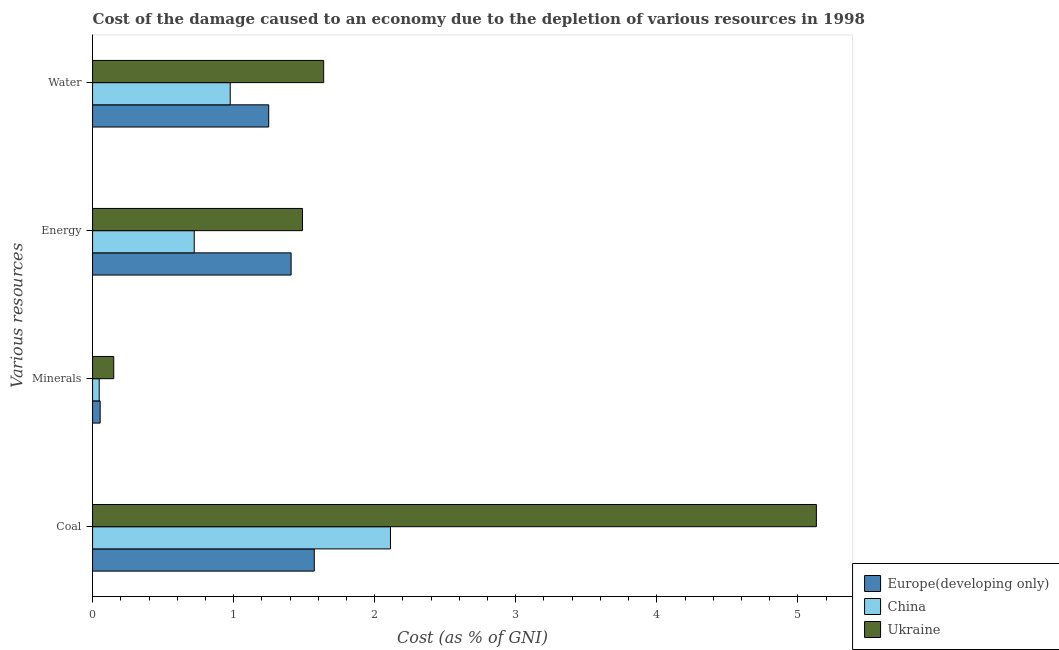How many different coloured bars are there?
Your answer should be compact. 3. How many groups of bars are there?
Your response must be concise. 4. Are the number of bars per tick equal to the number of legend labels?
Provide a short and direct response. Yes. Are the number of bars on each tick of the Y-axis equal?
Provide a short and direct response. Yes. What is the label of the 4th group of bars from the top?
Give a very brief answer. Coal. What is the cost of damage due to depletion of minerals in Ukraine?
Keep it short and to the point. 0.15. Across all countries, what is the maximum cost of damage due to depletion of water?
Provide a succinct answer. 1.64. Across all countries, what is the minimum cost of damage due to depletion of energy?
Keep it short and to the point. 0.72. In which country was the cost of damage due to depletion of energy maximum?
Give a very brief answer. Ukraine. What is the total cost of damage due to depletion of energy in the graph?
Keep it short and to the point. 3.62. What is the difference between the cost of damage due to depletion of energy in Ukraine and that in China?
Ensure brevity in your answer.  0.77. What is the difference between the cost of damage due to depletion of minerals in China and the cost of damage due to depletion of energy in Europe(developing only)?
Provide a succinct answer. -1.36. What is the average cost of damage due to depletion of water per country?
Provide a succinct answer. 1.29. What is the difference between the cost of damage due to depletion of energy and cost of damage due to depletion of coal in Ukraine?
Your answer should be compact. -3.64. What is the ratio of the cost of damage due to depletion of energy in Ukraine to that in China?
Offer a very short reply. 2.06. What is the difference between the highest and the second highest cost of damage due to depletion of energy?
Your response must be concise. 0.08. What is the difference between the highest and the lowest cost of damage due to depletion of coal?
Your response must be concise. 3.56. Is the sum of the cost of damage due to depletion of coal in Europe(developing only) and China greater than the maximum cost of damage due to depletion of energy across all countries?
Make the answer very short. Yes. What does the 1st bar from the top in Energy represents?
Make the answer very short. Ukraine. What does the 2nd bar from the bottom in Energy represents?
Offer a terse response. China. Are all the bars in the graph horizontal?
Offer a very short reply. Yes. How many countries are there in the graph?
Ensure brevity in your answer.  3. Does the graph contain any zero values?
Your answer should be compact. No. Does the graph contain grids?
Keep it short and to the point. No. How many legend labels are there?
Ensure brevity in your answer.  3. What is the title of the graph?
Your response must be concise. Cost of the damage caused to an economy due to the depletion of various resources in 1998 . Does "Turkey" appear as one of the legend labels in the graph?
Offer a very short reply. No. What is the label or title of the X-axis?
Give a very brief answer. Cost (as % of GNI). What is the label or title of the Y-axis?
Your response must be concise. Various resources. What is the Cost (as % of GNI) of Europe(developing only) in Coal?
Your answer should be compact. 1.57. What is the Cost (as % of GNI) of China in Coal?
Your answer should be compact. 2.11. What is the Cost (as % of GNI) in Ukraine in Coal?
Make the answer very short. 5.13. What is the Cost (as % of GNI) of Europe(developing only) in Minerals?
Your answer should be compact. 0.05. What is the Cost (as % of GNI) of China in Minerals?
Your response must be concise. 0.05. What is the Cost (as % of GNI) of Ukraine in Minerals?
Provide a short and direct response. 0.15. What is the Cost (as % of GNI) of Europe(developing only) in Energy?
Ensure brevity in your answer.  1.41. What is the Cost (as % of GNI) in China in Energy?
Provide a short and direct response. 0.72. What is the Cost (as % of GNI) in Ukraine in Energy?
Keep it short and to the point. 1.49. What is the Cost (as % of GNI) in Europe(developing only) in Water?
Your answer should be compact. 1.25. What is the Cost (as % of GNI) in China in Water?
Ensure brevity in your answer.  0.98. What is the Cost (as % of GNI) in Ukraine in Water?
Offer a terse response. 1.64. Across all Various resources, what is the maximum Cost (as % of GNI) of Europe(developing only)?
Make the answer very short. 1.57. Across all Various resources, what is the maximum Cost (as % of GNI) of China?
Your response must be concise. 2.11. Across all Various resources, what is the maximum Cost (as % of GNI) in Ukraine?
Offer a terse response. 5.13. Across all Various resources, what is the minimum Cost (as % of GNI) of Europe(developing only)?
Your answer should be compact. 0.05. Across all Various resources, what is the minimum Cost (as % of GNI) of China?
Your answer should be very brief. 0.05. Across all Various resources, what is the minimum Cost (as % of GNI) in Ukraine?
Your answer should be compact. 0.15. What is the total Cost (as % of GNI) in Europe(developing only) in the graph?
Your answer should be compact. 4.28. What is the total Cost (as % of GNI) in China in the graph?
Give a very brief answer. 3.86. What is the total Cost (as % of GNI) in Ukraine in the graph?
Offer a very short reply. 8.41. What is the difference between the Cost (as % of GNI) in Europe(developing only) in Coal and that in Minerals?
Make the answer very short. 1.52. What is the difference between the Cost (as % of GNI) in China in Coal and that in Minerals?
Your response must be concise. 2.06. What is the difference between the Cost (as % of GNI) of Ukraine in Coal and that in Minerals?
Make the answer very short. 4.98. What is the difference between the Cost (as % of GNI) of Europe(developing only) in Coal and that in Energy?
Make the answer very short. 0.16. What is the difference between the Cost (as % of GNI) in China in Coal and that in Energy?
Provide a short and direct response. 1.39. What is the difference between the Cost (as % of GNI) in Ukraine in Coal and that in Energy?
Offer a terse response. 3.64. What is the difference between the Cost (as % of GNI) in Europe(developing only) in Coal and that in Water?
Provide a succinct answer. 0.32. What is the difference between the Cost (as % of GNI) in China in Coal and that in Water?
Ensure brevity in your answer.  1.14. What is the difference between the Cost (as % of GNI) of Ukraine in Coal and that in Water?
Your answer should be compact. 3.49. What is the difference between the Cost (as % of GNI) of Europe(developing only) in Minerals and that in Energy?
Keep it short and to the point. -1.35. What is the difference between the Cost (as % of GNI) in China in Minerals and that in Energy?
Make the answer very short. -0.67. What is the difference between the Cost (as % of GNI) in Ukraine in Minerals and that in Energy?
Provide a succinct answer. -1.34. What is the difference between the Cost (as % of GNI) in Europe(developing only) in Minerals and that in Water?
Your answer should be very brief. -1.19. What is the difference between the Cost (as % of GNI) in China in Minerals and that in Water?
Offer a very short reply. -0.93. What is the difference between the Cost (as % of GNI) in Ukraine in Minerals and that in Water?
Ensure brevity in your answer.  -1.49. What is the difference between the Cost (as % of GNI) in Europe(developing only) in Energy and that in Water?
Ensure brevity in your answer.  0.16. What is the difference between the Cost (as % of GNI) in China in Energy and that in Water?
Keep it short and to the point. -0.26. What is the difference between the Cost (as % of GNI) of Ukraine in Energy and that in Water?
Your answer should be very brief. -0.15. What is the difference between the Cost (as % of GNI) in Europe(developing only) in Coal and the Cost (as % of GNI) in China in Minerals?
Provide a short and direct response. 1.52. What is the difference between the Cost (as % of GNI) of Europe(developing only) in Coal and the Cost (as % of GNI) of Ukraine in Minerals?
Ensure brevity in your answer.  1.42. What is the difference between the Cost (as % of GNI) in China in Coal and the Cost (as % of GNI) in Ukraine in Minerals?
Ensure brevity in your answer.  1.96. What is the difference between the Cost (as % of GNI) of Europe(developing only) in Coal and the Cost (as % of GNI) of China in Energy?
Offer a terse response. 0.85. What is the difference between the Cost (as % of GNI) of Europe(developing only) in Coal and the Cost (as % of GNI) of Ukraine in Energy?
Offer a terse response. 0.08. What is the difference between the Cost (as % of GNI) of China in Coal and the Cost (as % of GNI) of Ukraine in Energy?
Your answer should be compact. 0.62. What is the difference between the Cost (as % of GNI) in Europe(developing only) in Coal and the Cost (as % of GNI) in China in Water?
Offer a terse response. 0.6. What is the difference between the Cost (as % of GNI) of Europe(developing only) in Coal and the Cost (as % of GNI) of Ukraine in Water?
Your response must be concise. -0.07. What is the difference between the Cost (as % of GNI) of China in Coal and the Cost (as % of GNI) of Ukraine in Water?
Give a very brief answer. 0.47. What is the difference between the Cost (as % of GNI) of Europe(developing only) in Minerals and the Cost (as % of GNI) of China in Energy?
Keep it short and to the point. -0.67. What is the difference between the Cost (as % of GNI) in Europe(developing only) in Minerals and the Cost (as % of GNI) in Ukraine in Energy?
Provide a short and direct response. -1.43. What is the difference between the Cost (as % of GNI) of China in Minerals and the Cost (as % of GNI) of Ukraine in Energy?
Offer a terse response. -1.44. What is the difference between the Cost (as % of GNI) of Europe(developing only) in Minerals and the Cost (as % of GNI) of China in Water?
Provide a short and direct response. -0.92. What is the difference between the Cost (as % of GNI) in Europe(developing only) in Minerals and the Cost (as % of GNI) in Ukraine in Water?
Make the answer very short. -1.58. What is the difference between the Cost (as % of GNI) of China in Minerals and the Cost (as % of GNI) of Ukraine in Water?
Make the answer very short. -1.59. What is the difference between the Cost (as % of GNI) of Europe(developing only) in Energy and the Cost (as % of GNI) of China in Water?
Ensure brevity in your answer.  0.43. What is the difference between the Cost (as % of GNI) of Europe(developing only) in Energy and the Cost (as % of GNI) of Ukraine in Water?
Your response must be concise. -0.23. What is the difference between the Cost (as % of GNI) of China in Energy and the Cost (as % of GNI) of Ukraine in Water?
Your response must be concise. -0.92. What is the average Cost (as % of GNI) in Europe(developing only) per Various resources?
Your response must be concise. 1.07. What is the average Cost (as % of GNI) in China per Various resources?
Your answer should be very brief. 0.96. What is the average Cost (as % of GNI) in Ukraine per Various resources?
Your answer should be compact. 2.1. What is the difference between the Cost (as % of GNI) of Europe(developing only) and Cost (as % of GNI) of China in Coal?
Make the answer very short. -0.54. What is the difference between the Cost (as % of GNI) in Europe(developing only) and Cost (as % of GNI) in Ukraine in Coal?
Keep it short and to the point. -3.56. What is the difference between the Cost (as % of GNI) in China and Cost (as % of GNI) in Ukraine in Coal?
Provide a short and direct response. -3.02. What is the difference between the Cost (as % of GNI) of Europe(developing only) and Cost (as % of GNI) of China in Minerals?
Provide a succinct answer. 0.01. What is the difference between the Cost (as % of GNI) of Europe(developing only) and Cost (as % of GNI) of Ukraine in Minerals?
Keep it short and to the point. -0.1. What is the difference between the Cost (as % of GNI) in China and Cost (as % of GNI) in Ukraine in Minerals?
Ensure brevity in your answer.  -0.1. What is the difference between the Cost (as % of GNI) of Europe(developing only) and Cost (as % of GNI) of China in Energy?
Ensure brevity in your answer.  0.69. What is the difference between the Cost (as % of GNI) in Europe(developing only) and Cost (as % of GNI) in Ukraine in Energy?
Provide a succinct answer. -0.08. What is the difference between the Cost (as % of GNI) of China and Cost (as % of GNI) of Ukraine in Energy?
Give a very brief answer. -0.77. What is the difference between the Cost (as % of GNI) of Europe(developing only) and Cost (as % of GNI) of China in Water?
Keep it short and to the point. 0.27. What is the difference between the Cost (as % of GNI) of Europe(developing only) and Cost (as % of GNI) of Ukraine in Water?
Offer a terse response. -0.39. What is the difference between the Cost (as % of GNI) in China and Cost (as % of GNI) in Ukraine in Water?
Your answer should be compact. -0.66. What is the ratio of the Cost (as % of GNI) in Europe(developing only) in Coal to that in Minerals?
Your answer should be compact. 29.18. What is the ratio of the Cost (as % of GNI) of China in Coal to that in Minerals?
Give a very brief answer. 44.84. What is the ratio of the Cost (as % of GNI) of Ukraine in Coal to that in Minerals?
Your answer should be compact. 34.2. What is the ratio of the Cost (as % of GNI) of Europe(developing only) in Coal to that in Energy?
Your answer should be very brief. 1.12. What is the ratio of the Cost (as % of GNI) in China in Coal to that in Energy?
Provide a short and direct response. 2.93. What is the ratio of the Cost (as % of GNI) in Ukraine in Coal to that in Energy?
Give a very brief answer. 3.45. What is the ratio of the Cost (as % of GNI) of Europe(developing only) in Coal to that in Water?
Offer a terse response. 1.26. What is the ratio of the Cost (as % of GNI) in China in Coal to that in Water?
Provide a short and direct response. 2.16. What is the ratio of the Cost (as % of GNI) of Ukraine in Coal to that in Water?
Make the answer very short. 3.13. What is the ratio of the Cost (as % of GNI) of Europe(developing only) in Minerals to that in Energy?
Make the answer very short. 0.04. What is the ratio of the Cost (as % of GNI) in China in Minerals to that in Energy?
Ensure brevity in your answer.  0.07. What is the ratio of the Cost (as % of GNI) of Ukraine in Minerals to that in Energy?
Your answer should be very brief. 0.1. What is the ratio of the Cost (as % of GNI) in Europe(developing only) in Minerals to that in Water?
Offer a terse response. 0.04. What is the ratio of the Cost (as % of GNI) of China in Minerals to that in Water?
Your response must be concise. 0.05. What is the ratio of the Cost (as % of GNI) in Ukraine in Minerals to that in Water?
Give a very brief answer. 0.09. What is the ratio of the Cost (as % of GNI) in Europe(developing only) in Energy to that in Water?
Give a very brief answer. 1.13. What is the ratio of the Cost (as % of GNI) in China in Energy to that in Water?
Offer a very short reply. 0.74. What is the ratio of the Cost (as % of GNI) of Ukraine in Energy to that in Water?
Offer a terse response. 0.91. What is the difference between the highest and the second highest Cost (as % of GNI) in Europe(developing only)?
Your response must be concise. 0.16. What is the difference between the highest and the second highest Cost (as % of GNI) in China?
Ensure brevity in your answer.  1.14. What is the difference between the highest and the second highest Cost (as % of GNI) of Ukraine?
Provide a short and direct response. 3.49. What is the difference between the highest and the lowest Cost (as % of GNI) of Europe(developing only)?
Your answer should be very brief. 1.52. What is the difference between the highest and the lowest Cost (as % of GNI) in China?
Provide a succinct answer. 2.06. What is the difference between the highest and the lowest Cost (as % of GNI) in Ukraine?
Offer a very short reply. 4.98. 